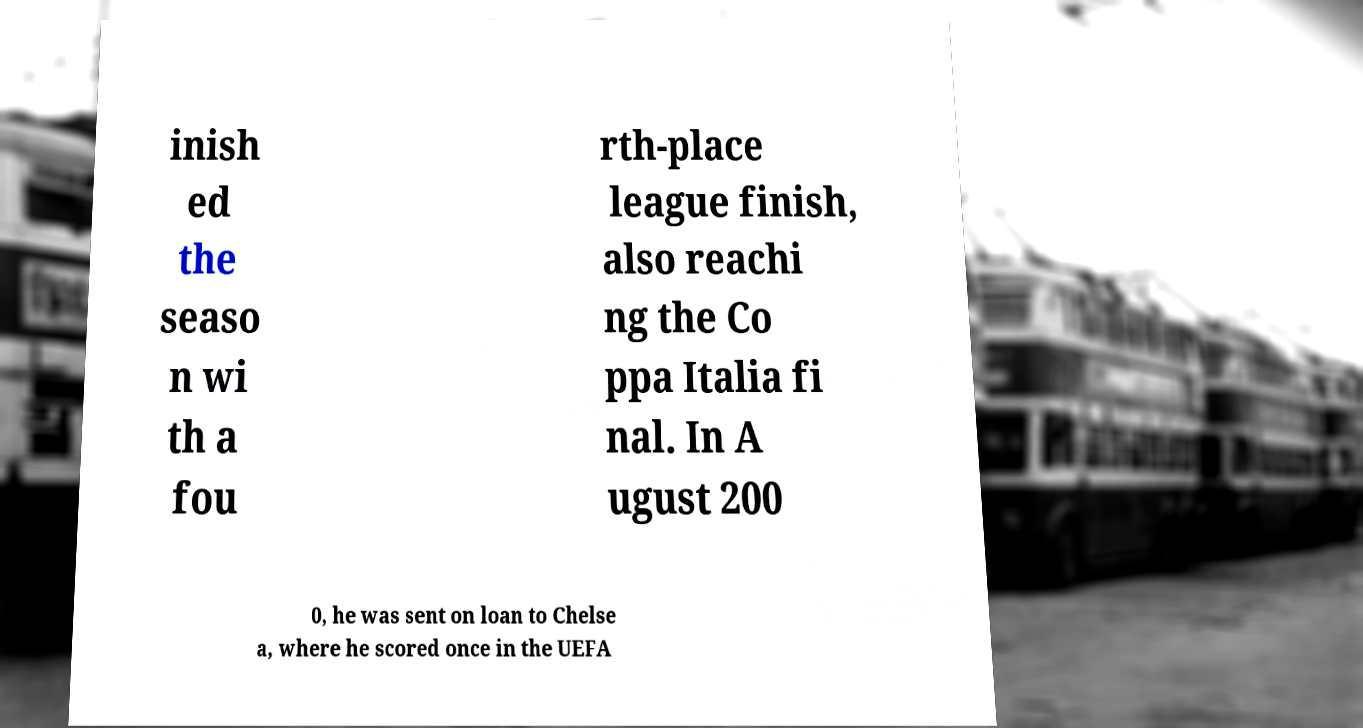What messages or text are displayed in this image? I need them in a readable, typed format. inish ed the seaso n wi th a fou rth-place league finish, also reachi ng the Co ppa Italia fi nal. In A ugust 200 0, he was sent on loan to Chelse a, where he scored once in the UEFA 